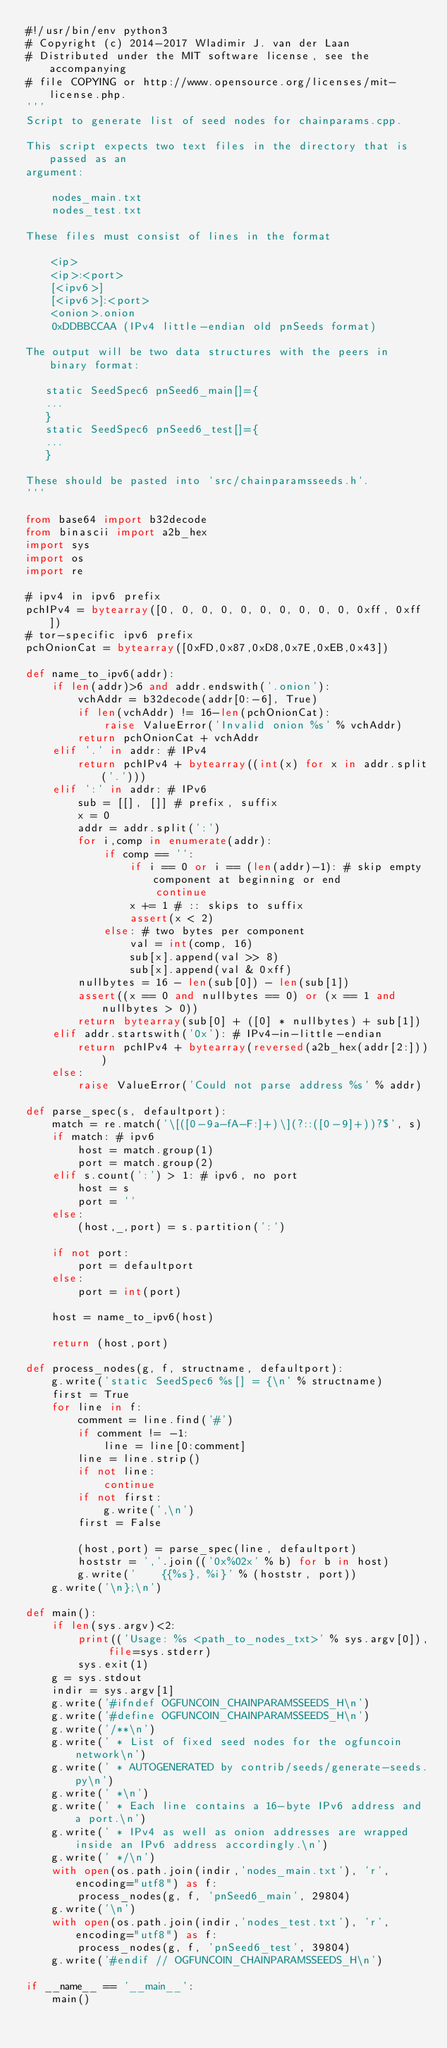Convert code to text. <code><loc_0><loc_0><loc_500><loc_500><_Python_>#!/usr/bin/env python3
# Copyright (c) 2014-2017 Wladimir J. van der Laan
# Distributed under the MIT software license, see the accompanying
# file COPYING or http://www.opensource.org/licenses/mit-license.php.
'''
Script to generate list of seed nodes for chainparams.cpp.

This script expects two text files in the directory that is passed as an
argument:

    nodes_main.txt
    nodes_test.txt

These files must consist of lines in the format

    <ip>
    <ip>:<port>
    [<ipv6>]
    [<ipv6>]:<port>
    <onion>.onion
    0xDDBBCCAA (IPv4 little-endian old pnSeeds format)

The output will be two data structures with the peers in binary format:

   static SeedSpec6 pnSeed6_main[]={
   ...
   }
   static SeedSpec6 pnSeed6_test[]={
   ...
   }

These should be pasted into `src/chainparamsseeds.h`.
'''

from base64 import b32decode
from binascii import a2b_hex
import sys
import os
import re

# ipv4 in ipv6 prefix
pchIPv4 = bytearray([0, 0, 0, 0, 0, 0, 0, 0, 0, 0, 0xff, 0xff])
# tor-specific ipv6 prefix
pchOnionCat = bytearray([0xFD,0x87,0xD8,0x7E,0xEB,0x43])

def name_to_ipv6(addr):
    if len(addr)>6 and addr.endswith('.onion'):
        vchAddr = b32decode(addr[0:-6], True)
        if len(vchAddr) != 16-len(pchOnionCat):
            raise ValueError('Invalid onion %s' % vchAddr)
        return pchOnionCat + vchAddr
    elif '.' in addr: # IPv4
        return pchIPv4 + bytearray((int(x) for x in addr.split('.')))
    elif ':' in addr: # IPv6
        sub = [[], []] # prefix, suffix
        x = 0
        addr = addr.split(':')
        for i,comp in enumerate(addr):
            if comp == '':
                if i == 0 or i == (len(addr)-1): # skip empty component at beginning or end
                    continue
                x += 1 # :: skips to suffix
                assert(x < 2)
            else: # two bytes per component
                val = int(comp, 16)
                sub[x].append(val >> 8)
                sub[x].append(val & 0xff)
        nullbytes = 16 - len(sub[0]) - len(sub[1])
        assert((x == 0 and nullbytes == 0) or (x == 1 and nullbytes > 0))
        return bytearray(sub[0] + ([0] * nullbytes) + sub[1])
    elif addr.startswith('0x'): # IPv4-in-little-endian
        return pchIPv4 + bytearray(reversed(a2b_hex(addr[2:])))
    else:
        raise ValueError('Could not parse address %s' % addr)

def parse_spec(s, defaultport):
    match = re.match('\[([0-9a-fA-F:]+)\](?::([0-9]+))?$', s)
    if match: # ipv6
        host = match.group(1)
        port = match.group(2)
    elif s.count(':') > 1: # ipv6, no port
        host = s
        port = ''
    else:
        (host,_,port) = s.partition(':')

    if not port:
        port = defaultport
    else:
        port = int(port)

    host = name_to_ipv6(host)

    return (host,port)

def process_nodes(g, f, structname, defaultport):
    g.write('static SeedSpec6 %s[] = {\n' % structname)
    first = True
    for line in f:
        comment = line.find('#')
        if comment != -1:
            line = line[0:comment]
        line = line.strip()
        if not line:
            continue
        if not first:
            g.write(',\n')
        first = False

        (host,port) = parse_spec(line, defaultport)
        hoststr = ','.join(('0x%02x' % b) for b in host)
        g.write('    {{%s}, %i}' % (hoststr, port))
    g.write('\n};\n')

def main():
    if len(sys.argv)<2:
        print(('Usage: %s <path_to_nodes_txt>' % sys.argv[0]), file=sys.stderr)
        sys.exit(1)
    g = sys.stdout
    indir = sys.argv[1]
    g.write('#ifndef OGFUNCOIN_CHAINPARAMSSEEDS_H\n')
    g.write('#define OGFUNCOIN_CHAINPARAMSSEEDS_H\n')
    g.write('/**\n')
    g.write(' * List of fixed seed nodes for the ogfuncoin network\n')
    g.write(' * AUTOGENERATED by contrib/seeds/generate-seeds.py\n')
    g.write(' *\n')
    g.write(' * Each line contains a 16-byte IPv6 address and a port.\n')
    g.write(' * IPv4 as well as onion addresses are wrapped inside an IPv6 address accordingly.\n')
    g.write(' */\n')
    with open(os.path.join(indir,'nodes_main.txt'), 'r', encoding="utf8") as f:
        process_nodes(g, f, 'pnSeed6_main', 29804)
    g.write('\n')
    with open(os.path.join(indir,'nodes_test.txt'), 'r', encoding="utf8") as f:
        process_nodes(g, f, 'pnSeed6_test', 39804)
    g.write('#endif // OGFUNCOIN_CHAINPARAMSSEEDS_H\n')

if __name__ == '__main__':
    main()

</code> 